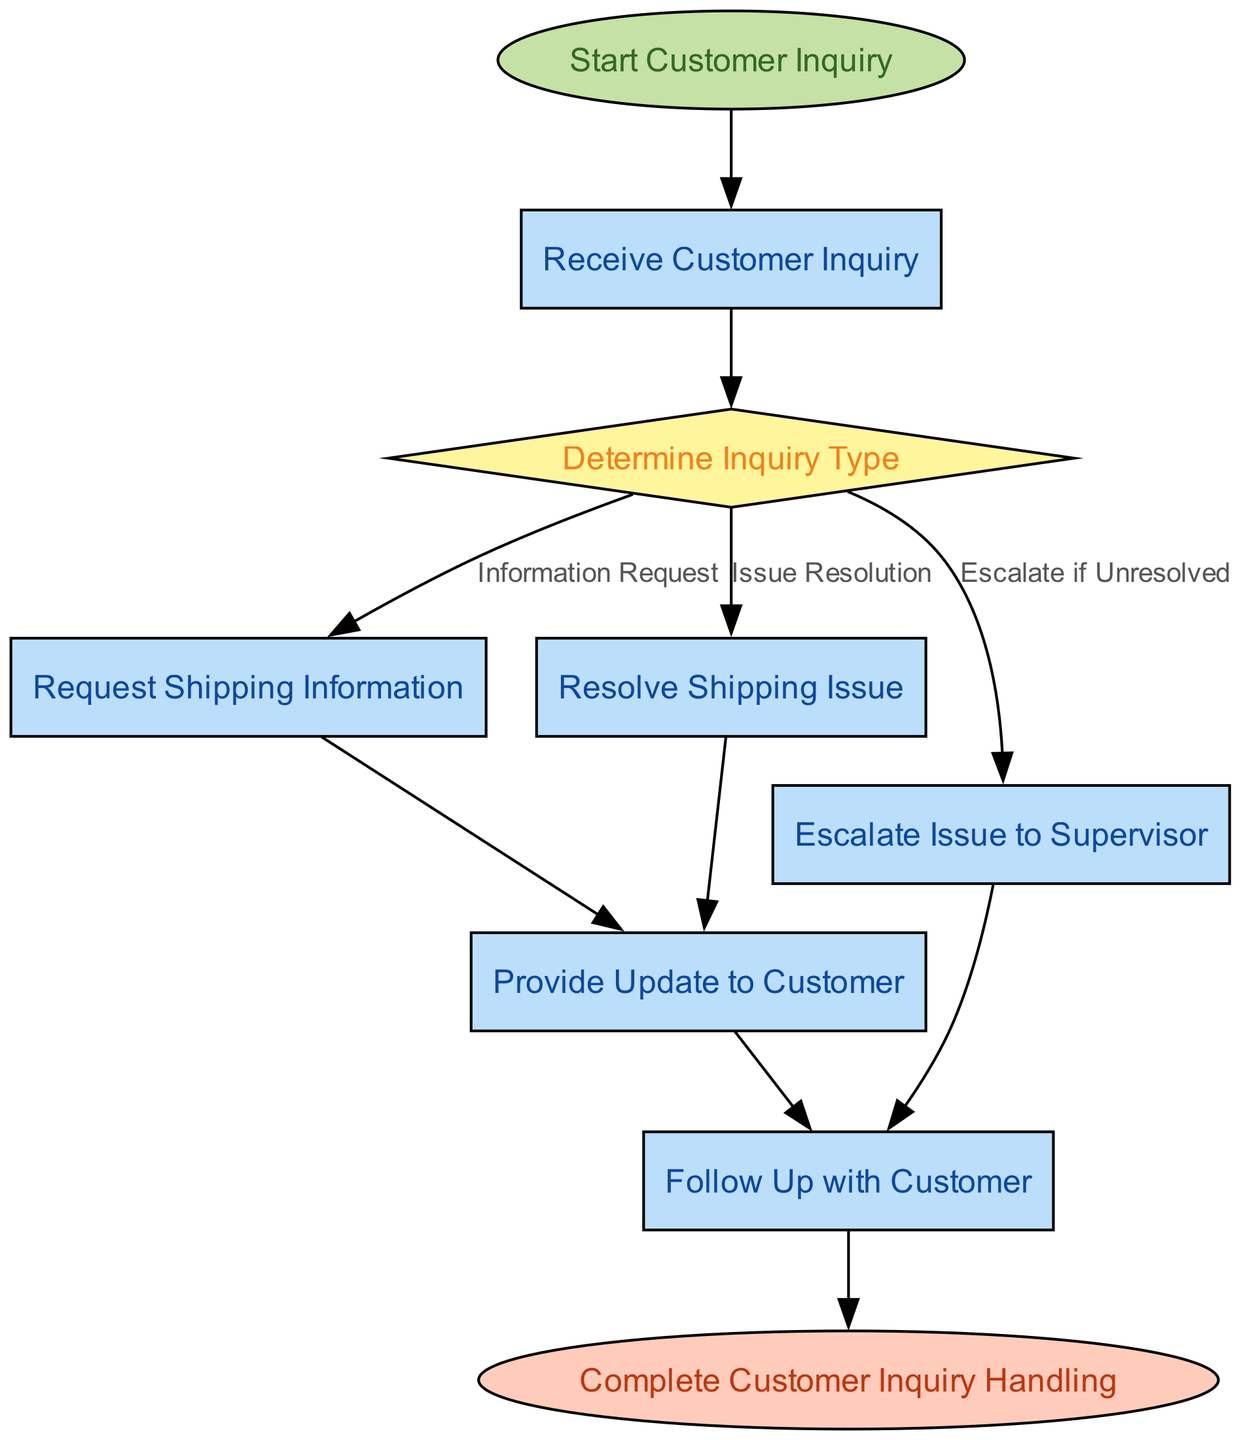What is the first step in handling customer inquiries? The first step is labeled "Start Customer Inquiry," which indicates the initial point in the flow for handling customer inquiries.
Answer: Start Customer Inquiry How many process nodes are there in the flow? By reviewing the nodes in the flow, we can identify four distinct process nodes: "Receive Customer Inquiry," "Request Shipping Information," "Resolve Shipping Issue," and "Provide Update to Customer."
Answer: Four What is the outcome if the inquiry type is determined as "Issue Resolution"? If the inquiry type is determined as "Issue Resolution," the flow leads to the next action: "Resolve Shipping Issue," where the actual problem will be addressed.
Answer: Resolve Shipping Issue What happens if an issue remains unresolved? If the issue is unresolved, the flow directs to "Escalate Issue to Supervisor," indicating that the problem needs higher-level intervention.
Answer: Escalate Issue to Supervisor What is the last step of the inquiry handling process? The last step in the flow is labeled "Complete Customer Inquiry Handling," marking the end of the inquiry process.
Answer: Complete Customer Inquiry Handling Which node follows the "Provide Update to Customer" process? After "Provide Update to Customer," the subsequent step is "Follow Up with Customer," indicating the next action taken in the process.
Answer: Follow Up with Customer How is an unresolved inquiry bound to escalate? An unresolved inquiry is indicated to escalate through the decision node "Determine Inquiry Type," which specifies that unresolved issues lead to "Escalate Issue to Supervisor."
Answer: Escalate Issue to Supervisor What shape represents decision nodes in the diagram? The decision nodes are represented in a diamond shape, which is a common visual cue used in flow charts to denote decision-making points.
Answer: Diamond How many edges originate from the "determineType" node? There are four edges originating from the "determineType" node, connecting it to "requestShippingInfo," "resolveIssue," "escalateIssue," and leading subsequently to "provideUpdate."
Answer: Four 